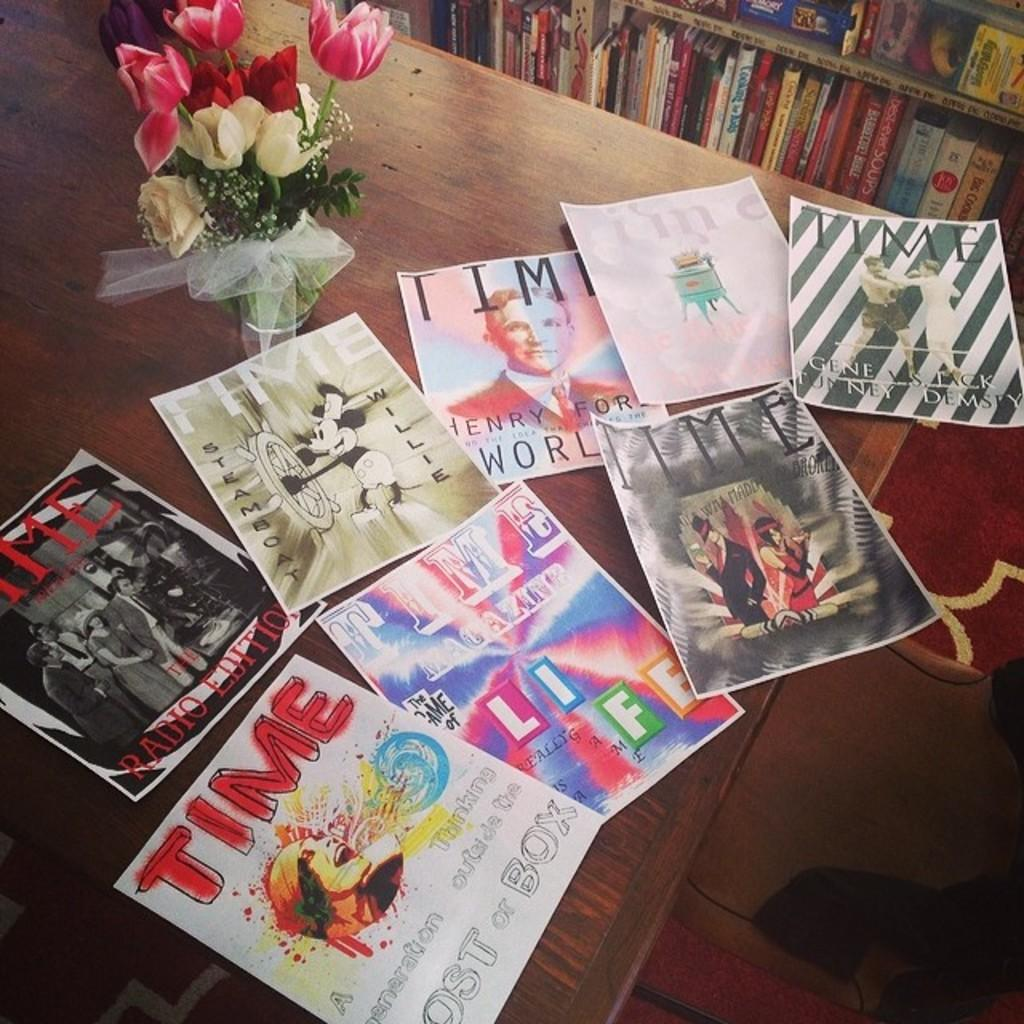<image>
Relay a brief, clear account of the picture shown. Several Time magazine images are scattered on a table. 